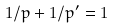<formula> <loc_0><loc_0><loc_500><loc_500>1 / p + 1 / p ^ { \prime } = 1</formula> 